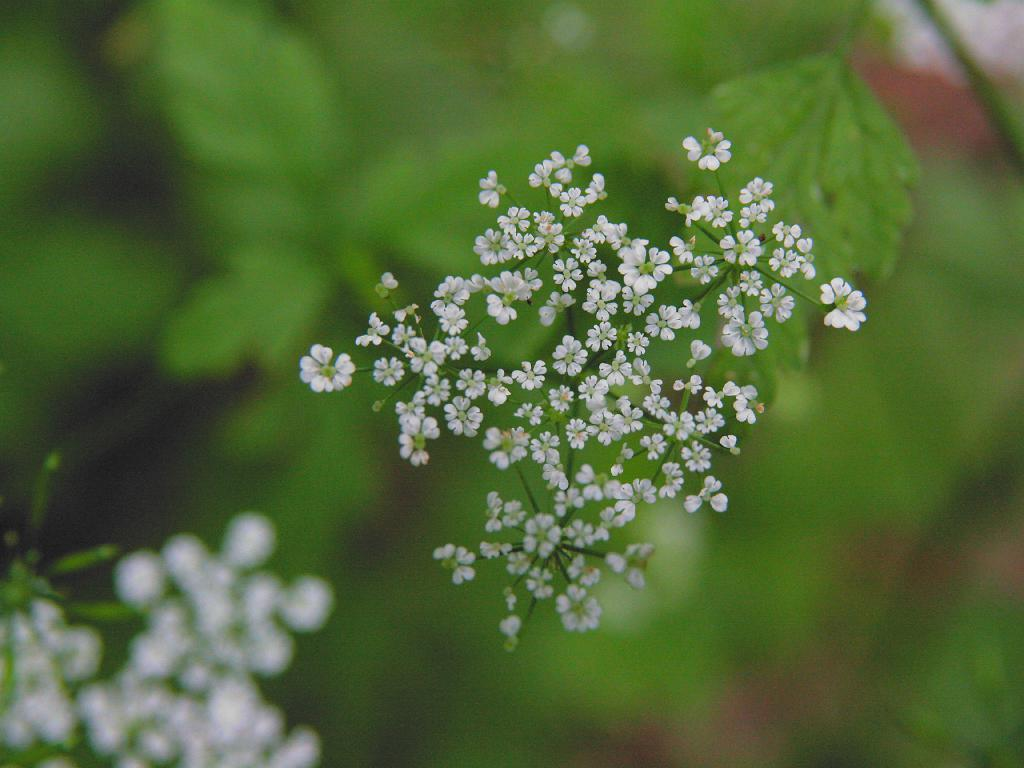What type of living organisms can be seen in the image? There are flowers in the image. Where are the flowers located? The flowers are on plants. What type of drain is visible in the image? There is no drain present in the image; it features flowers on plants. What type of work is being done in the image? There is no work being done in the image; it features flowers on plants. 